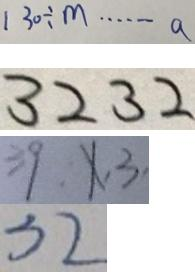Convert formula to latex. <formula><loc_0><loc_0><loc_500><loc_500>1 3 0 \div m \cdots a 
 3 2 3 2 
 3 9 , x , 3 , 
 3 2</formula> 